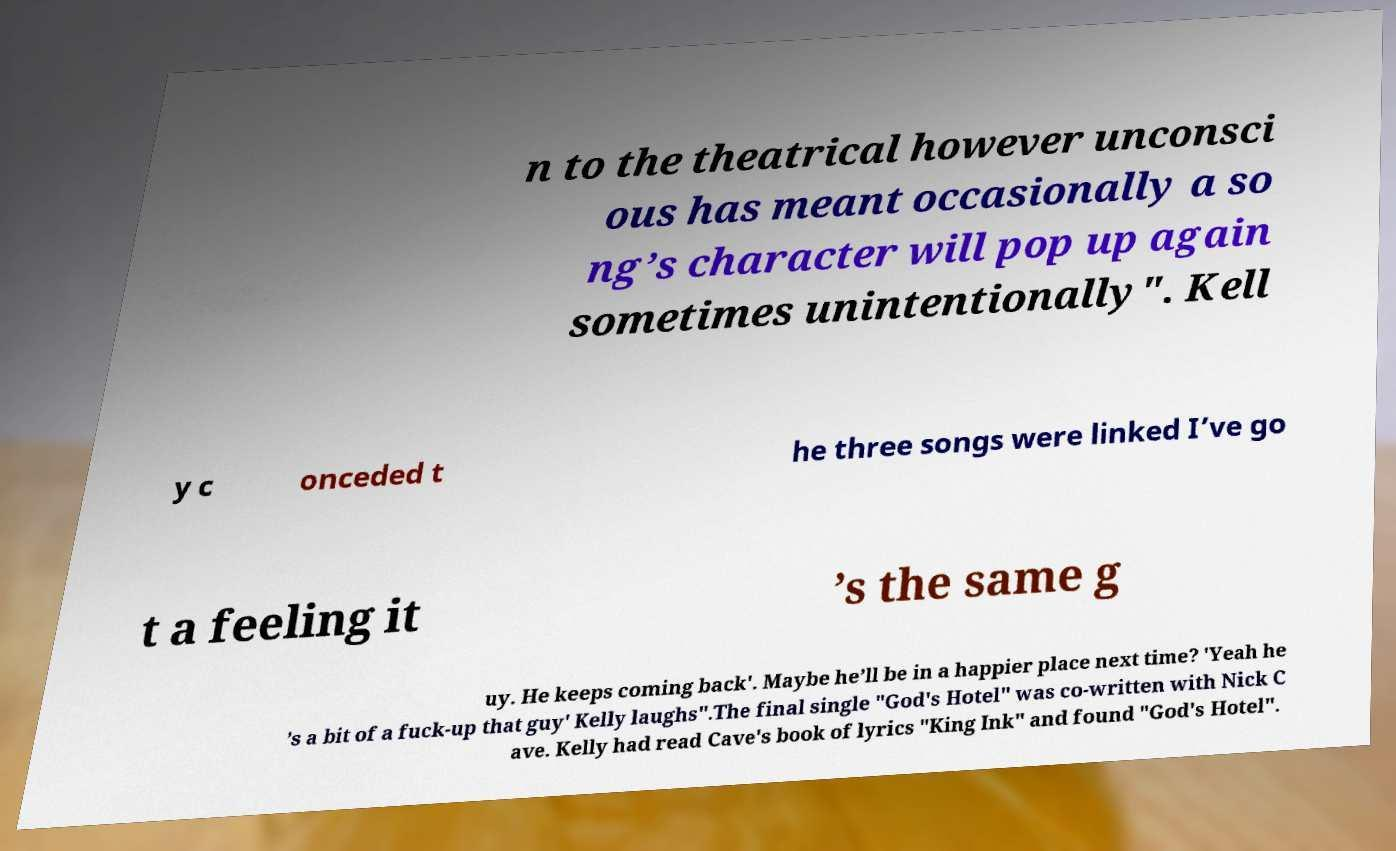Please read and relay the text visible in this image. What does it say? n to the theatrical however unconsci ous has meant occasionally a so ng’s character will pop up again sometimes unintentionally". Kell y c onceded t he three songs were linked I’ve go t a feeling it ’s the same g uy. He keeps coming back'. Maybe he’ll be in a happier place next time? 'Yeah he ’s a bit of a fuck-up that guy' Kelly laughs".The final single "God's Hotel" was co-written with Nick C ave. Kelly had read Cave's book of lyrics "King Ink" and found "God's Hotel". 